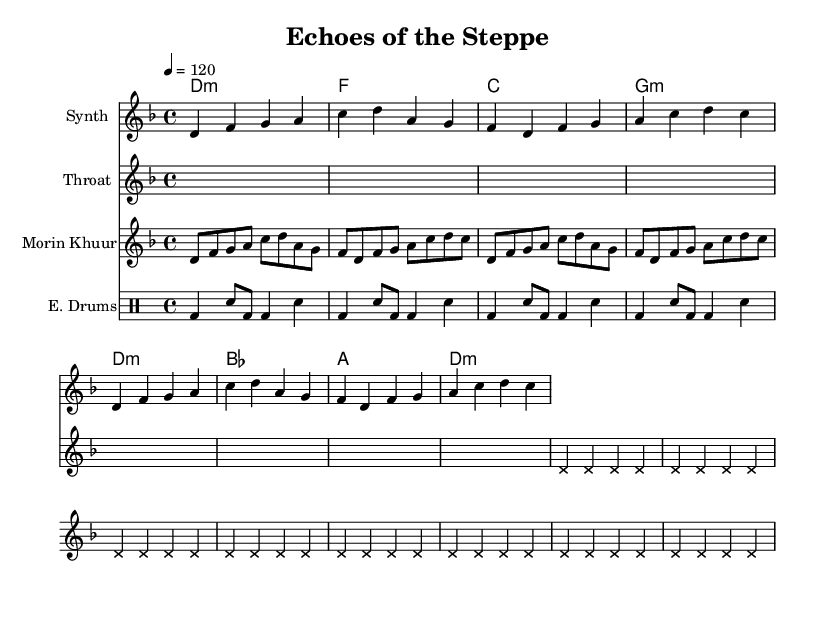What is the key signature of this music? The key signature is D minor, which has one flat (B♭). This is indicated at the beginning of the score, where the key is specified in the global settings.
Answer: D minor What is the time signature of the piece? The time signature is 4/4, which is shown in the global settings. This means there are four beats in each measure and the quarter note gets one beat.
Answer: 4/4 What is the tempo marking given in the score? The tempo marking indicates a tempo of 120 beats per minute, specified as "4 = 120" in the global section. This means each quarter note is played at this speed.
Answer: 120 How many measures are there in the synthesizer part? The synthesizer part contains a total of 8 measures, as indicated by the repeated sections marked with "repeat unfold 2" and the measure lengths shown.
Answer: 8 What type of traditional music technique is incorporated in this piece? The piece incorporates throat singing techniques, which is indicated by the staff labeled "Throat" that features a sustained note pattern typical of this vocal style.
Answer: Throat singing What kind of instrument is represented by "Morin Khuur"? The "Morin Khuur" represents a traditional Mongolian string instrument, which is explicitly named in the staff and is characterized by its unique melodic line in the music.
Answer: String instrument 